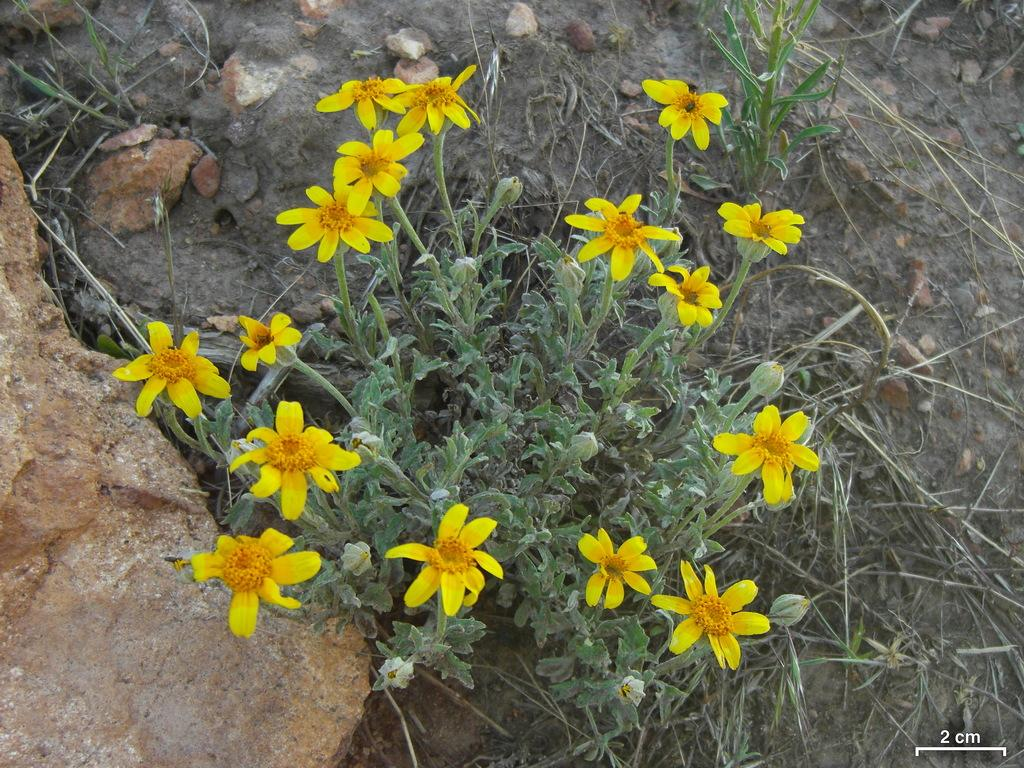What type of plant life is present in the image? There are flowers, buds, and leaves in the image. Can you describe the stage of growth for the plants in the image? The presence of buds suggests that some of the plants are in the early stages of growth. What can be seen in the background of the image? There are stones visible in the background of the image. What type of legal advice is the parent seeking in the image? There is no parent or legal advice present in the image; it features flowers, buds, leaves, and stones. 